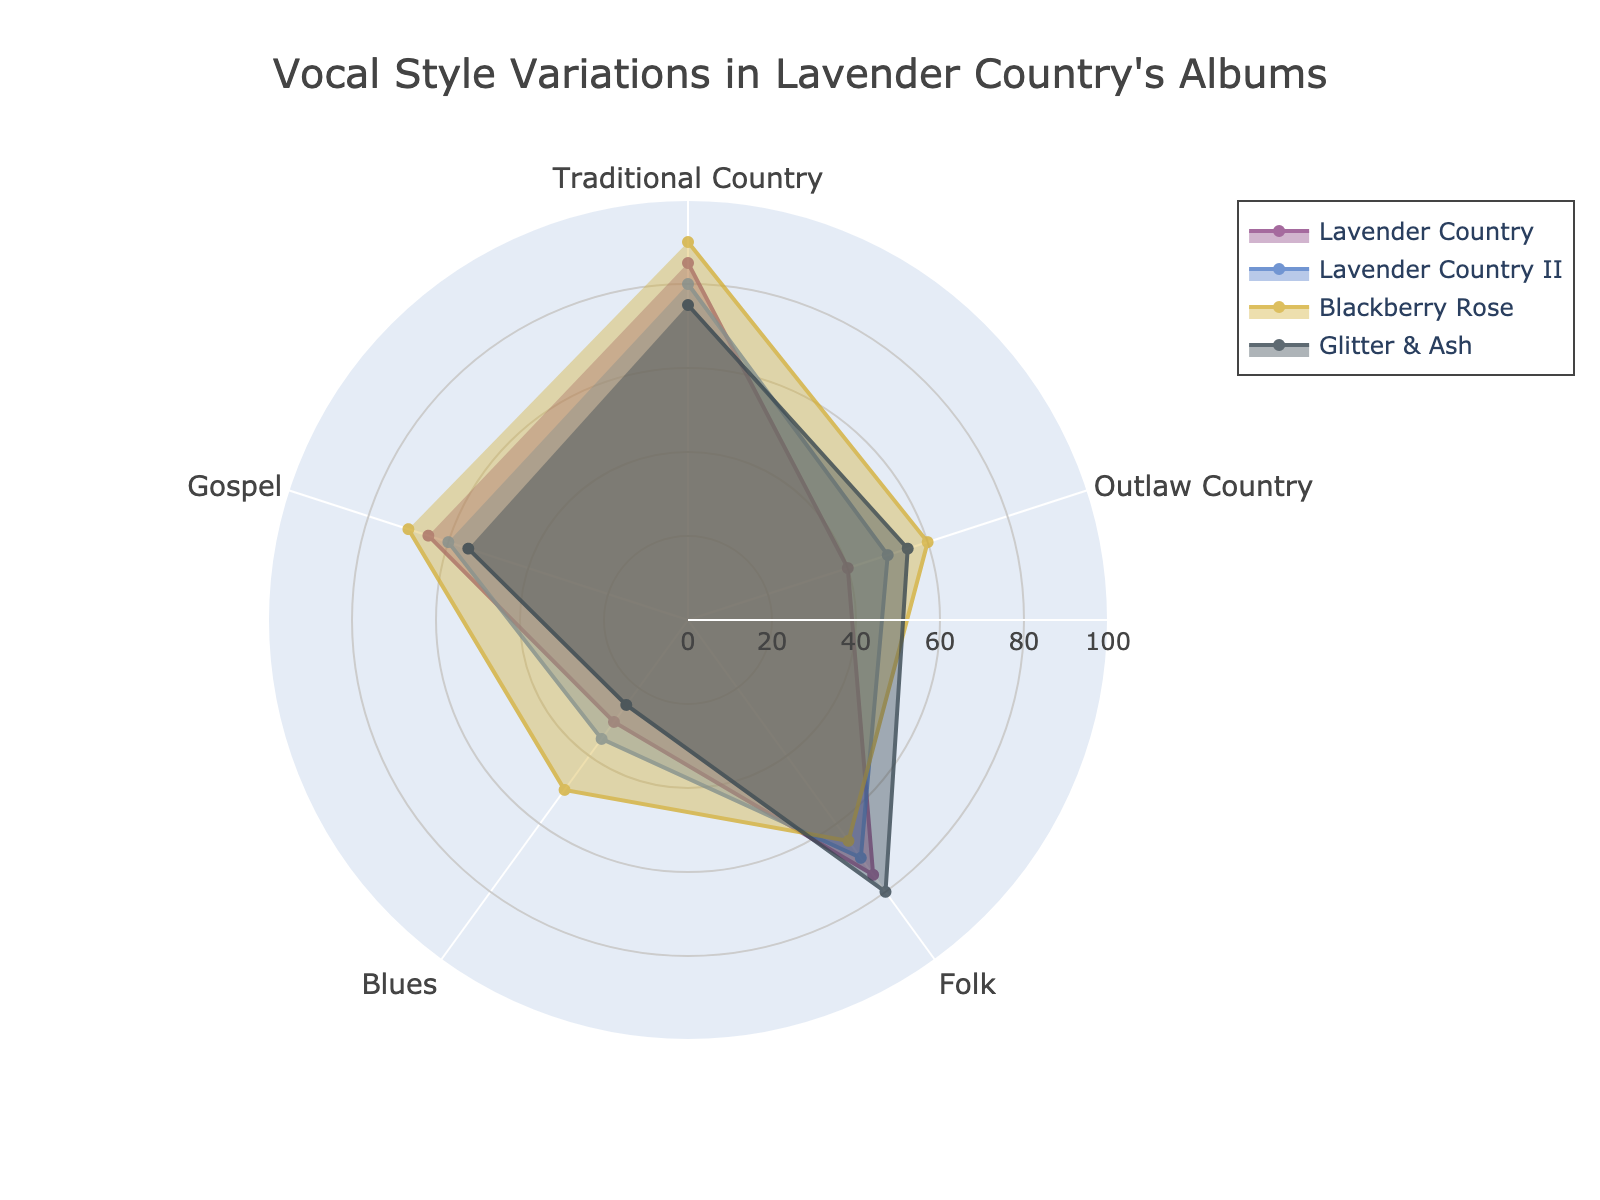What is the title of the radar chart? The title of the radar chart is prominently displayed at the top of the figure, providing a clear indication of what the chart represents.
Answer: Vocal Style Variations in Lavender Country's Albums Which album has the highest value for Traditional Country? Upon examining the radar chart, you will notice that the album with the highest point on the Traditional Country axis is clearly identifiable by the outermost point on that axis.
Answer: Blackberry Rose What are the vocal style categories shown on the radar chart? The radar chart typically displays different categories as spokes radiating from the center, each representing a specific dimension of the data plotted.
Answer: Traditional Country, Outlaw Country, Folk, Blues, Gospel How do the values for Blues in "Lavender Country" and "Blackberry Rose" compare? To compare these two albums, look at the points where each album intersects the Blues axis and compare their radial distances from the center.
Answer: Blackberry Rose has a higher value for Blues than Lavender Country What is the average value of Gospel in all the albums? To find the average, sum the Gospel values for all albums and then divide by the number of albums. The values are 65, 60, 70, and 55. Adding these gives 250, and dividing by 4 albums gives an average of 62.5.
Answer: 62.5 Which album has the lowest value for Folk? By examining the points associated with each album on the Folk axis, you can determine which one is closest to the center, indicating the lowest value.
Answer: Blackberry Rose How much higher is the value of Outlaw Country in "Blackberry Rose" compared to "Lavender Country"? Subtract the value of Outlaw Country for Lavender Country from that of Blackberry Rose. The values are 60 for Blackberry Rose and 40 for Lavender Country, thus the difference is 20.
Answer: 20 For which album does Outlaw Country have the greatest contribution compared to its other vocal styles? By examining the proportions of each vocal style within an album, identify the album where the Outlaw Country segment is the largest relative to its other segments.
Answer: Blackberry Rose Which album has the most balanced distribution across all vocal styles? For this, you need to visually assess which album shows a radar plot with relatively equal distances on each spoke, indicating a balanced distribution.
Answer: Glitter & Ash If you were to arrange the albums in ascending order of their Traditional Country values, what order would they be in? Look at the Traditional Country values for each album and arrange them from the smallest to the largest. The values are 75, 80, 85, and 90. Match these values to their respective albums.
Answer: Glitter & Ash, Lavender Country II, Lavender Country, Blackberry Rose 